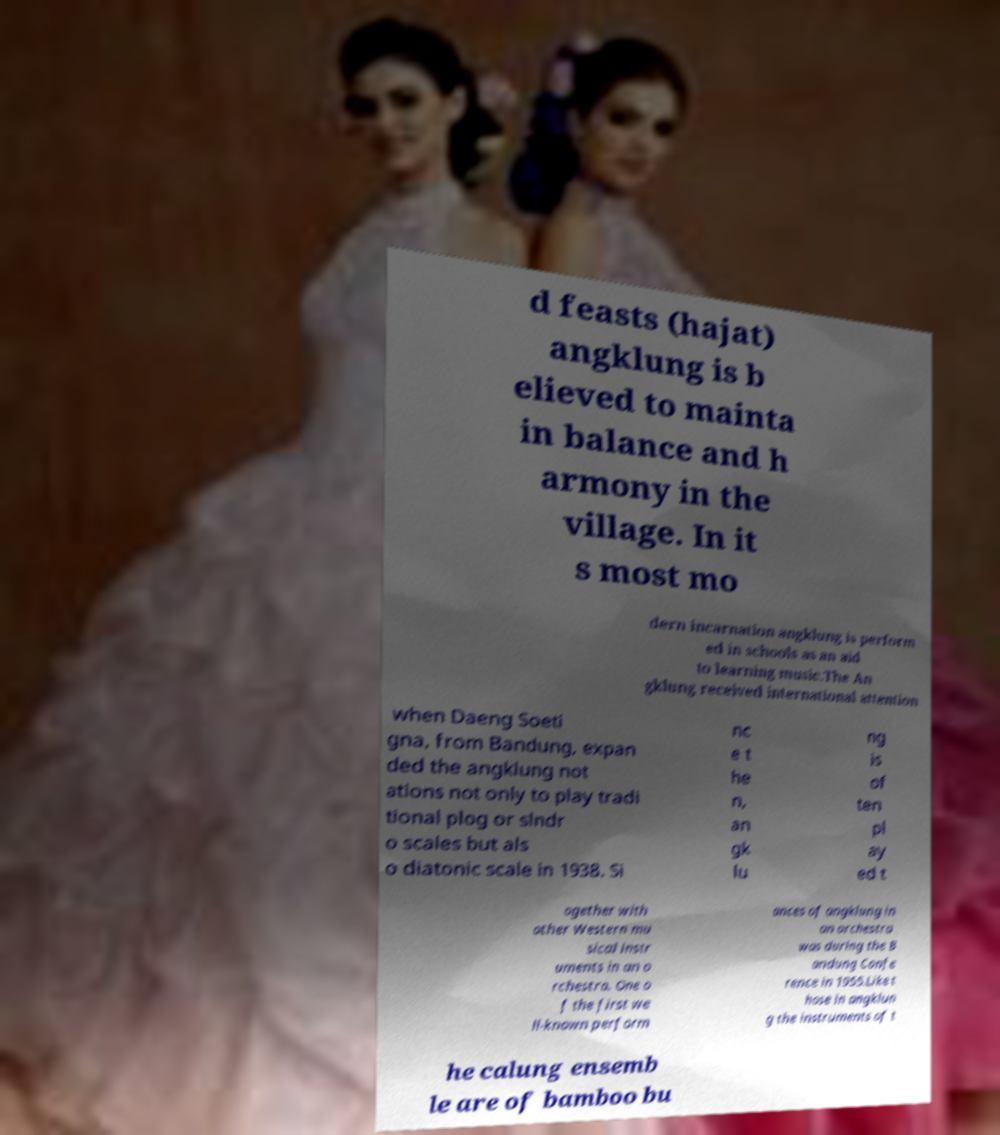Can you accurately transcribe the text from the provided image for me? d feasts (hajat) angklung is b elieved to mainta in balance and h armony in the village. In it s most mo dern incarnation angklung is perform ed in schools as an aid to learning music.The An gklung received international attention when Daeng Soeti gna, from Bandung, expan ded the angklung not ations not only to play tradi tional plog or slndr o scales but als o diatonic scale in 1938. Si nc e t he n, an gk lu ng is of ten pl ay ed t ogether with other Western mu sical instr uments in an o rchestra. One o f the first we ll-known perform ances of angklung in an orchestra was during the B andung Confe rence in 1955.Like t hose in angklun g the instruments of t he calung ensemb le are of bamboo bu 